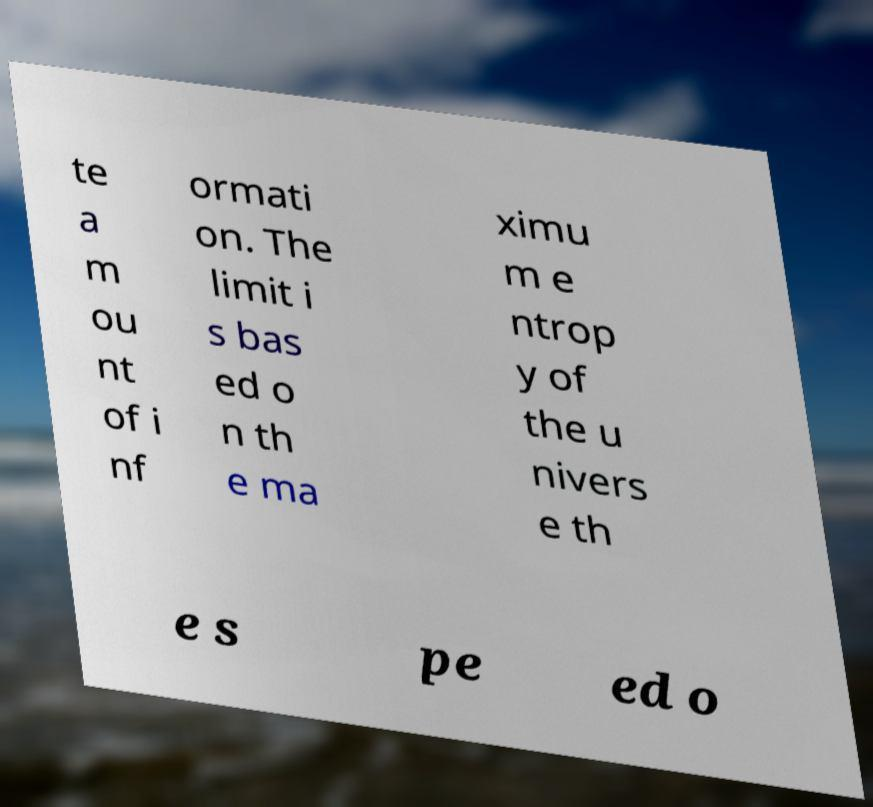Can you read and provide the text displayed in the image?This photo seems to have some interesting text. Can you extract and type it out for me? te a m ou nt of i nf ormati on. The limit i s bas ed o n th e ma ximu m e ntrop y of the u nivers e th e s pe ed o 